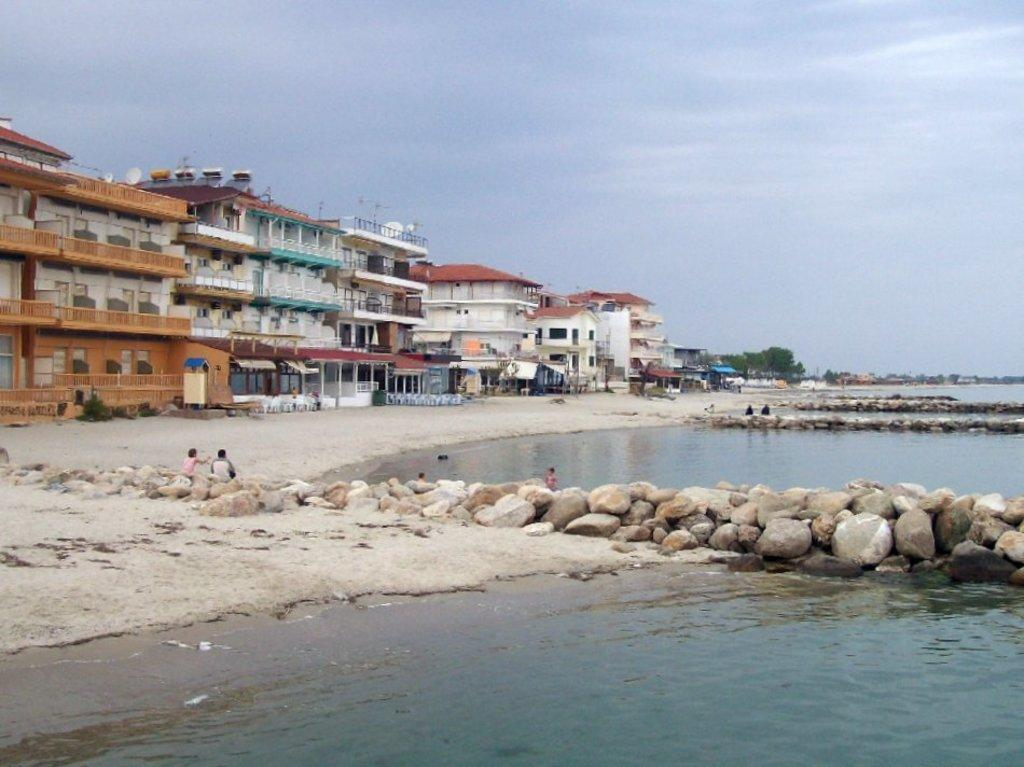What type of structures can be seen in the image? There are buildings in the image. What natural elements are present in the image? There are trees in the image. Are there any living beings visible in the image? Yes, there are people in the image. What can be seen at the bottom of the image? There is water and rocks visible at the bottom of the image. Can you see a quill being used by one of the people? There is no quill present in the image. What is the tendency of the rocks to move in the image? The rocks are stationary in the image and do not exhibit any tendency to move. 